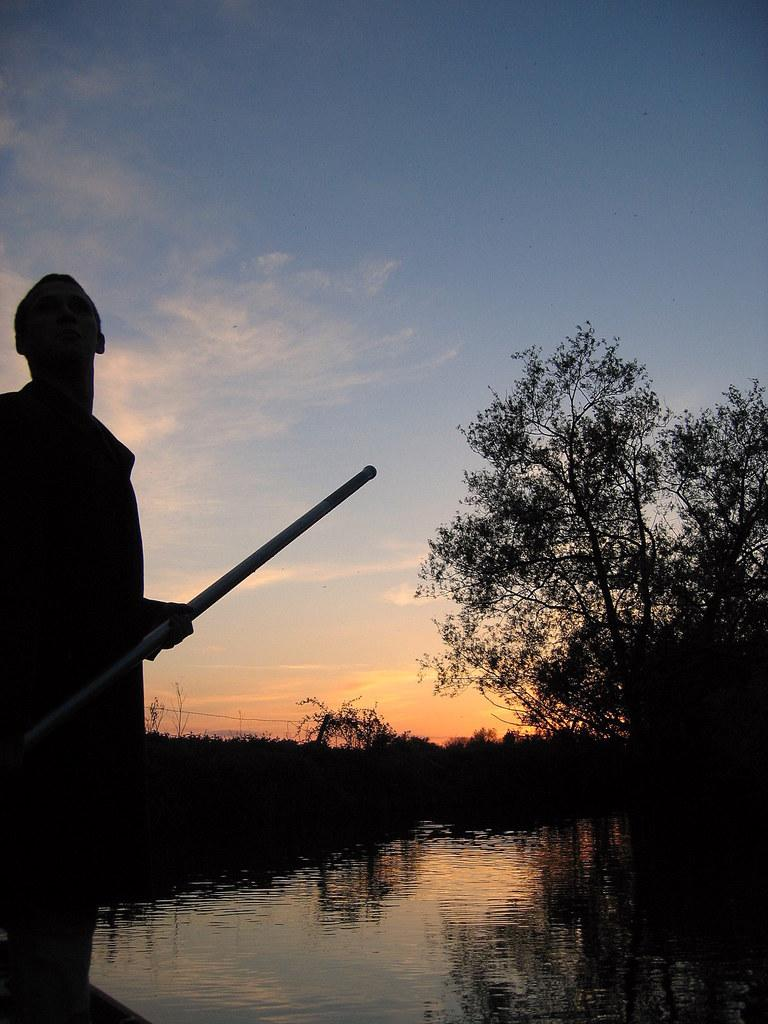What is the person in the image doing? The person is standing and holding a stick in the image. What can be seen in the background of the image? There is water, trees, and the sky visible in the image. What is the condition of the sky in the image? The sky is visible with clouds in the image. Can you tell me what grade the person in the image is in? There is no information about the person's grade in the image. What type of key is the person using to interact with the water in the image? There is no key present in the image, and the person is not interacting with the water. 